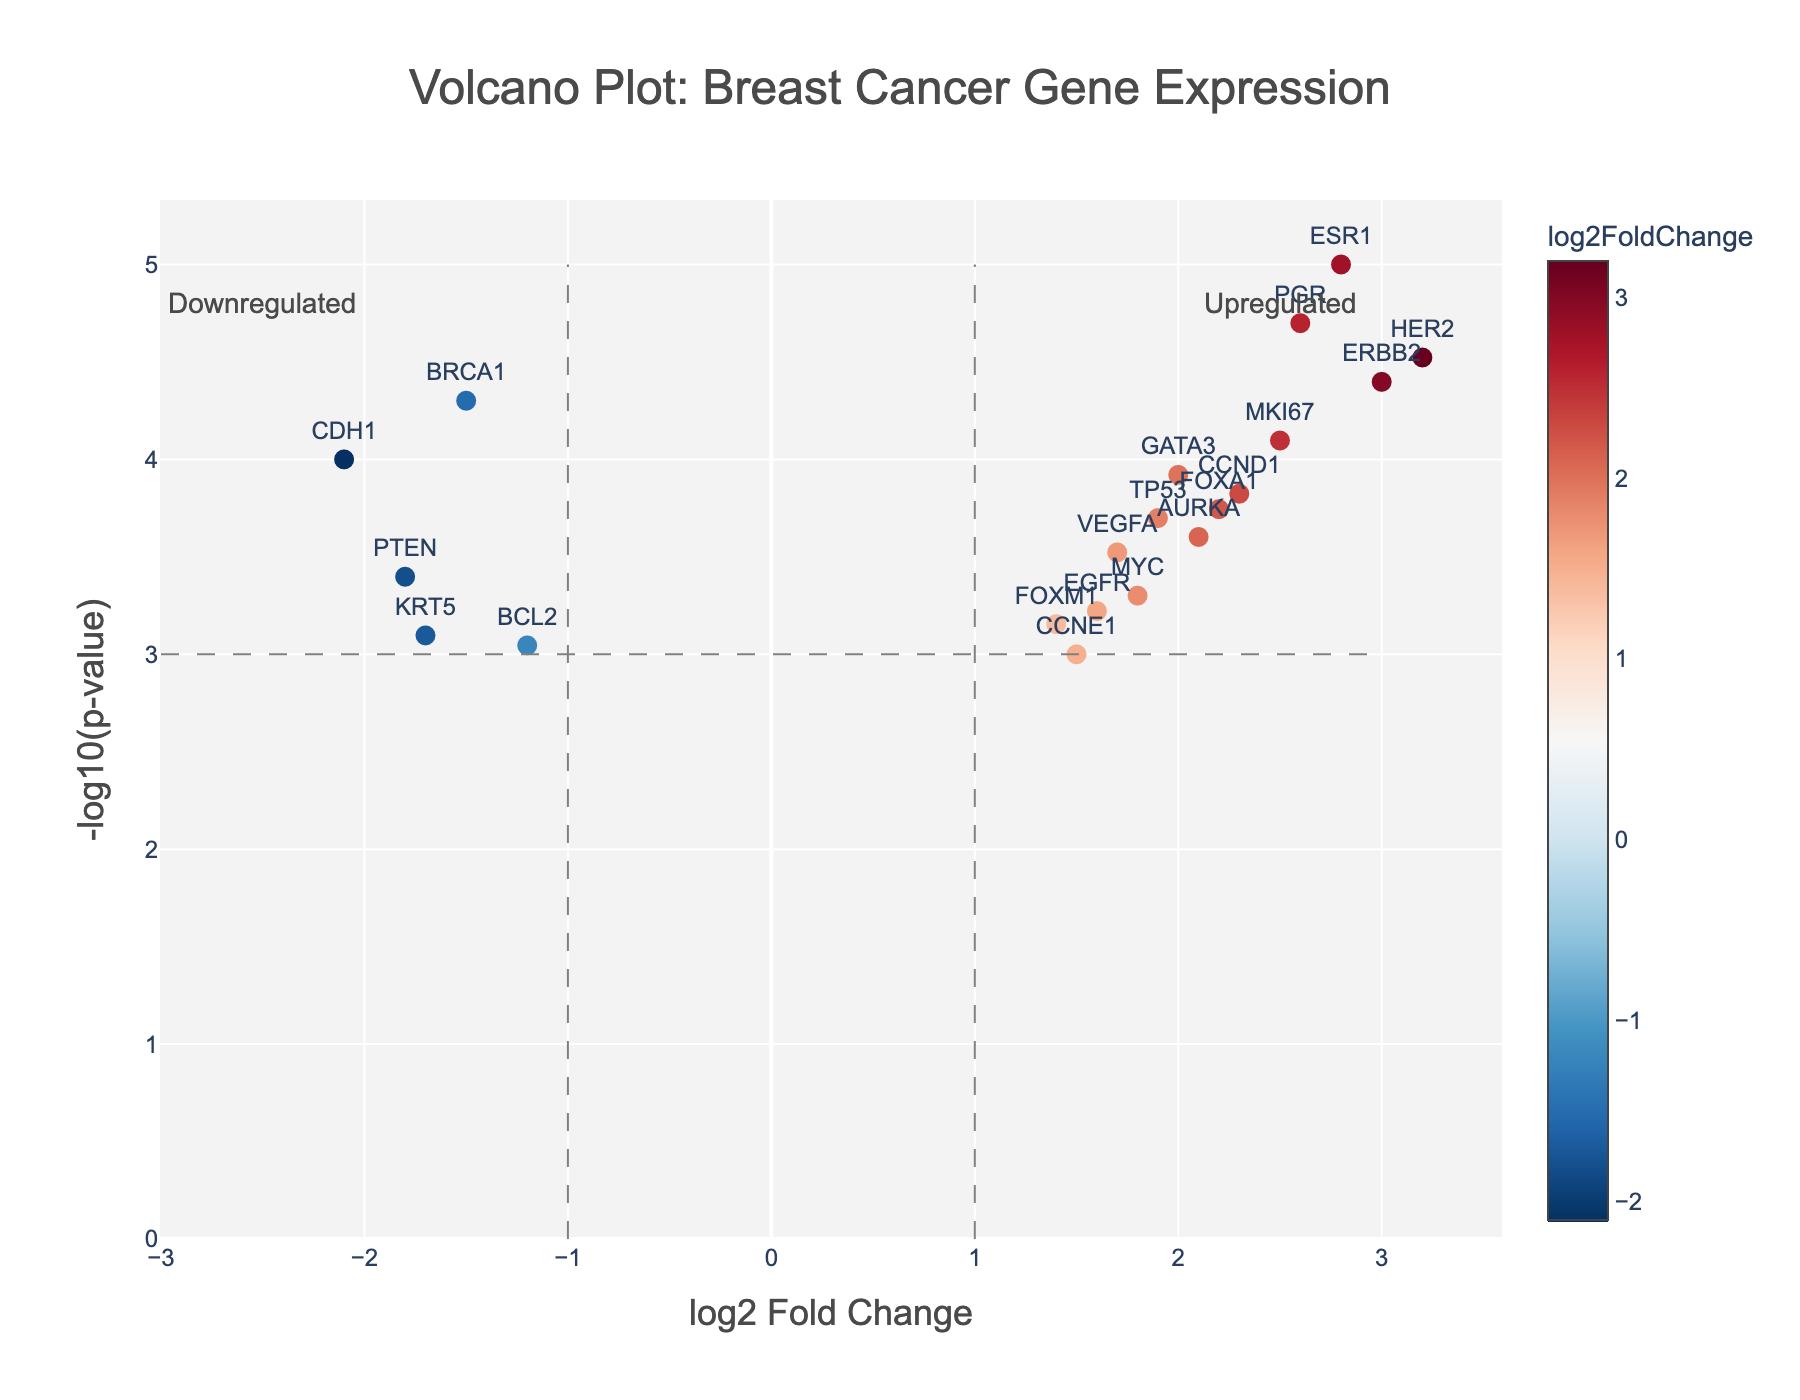What's the title of the plot? The title of the plot is provided at the top in a larger font size. It reads "Volcano Plot: Breast Cancer Gene Expression".
Answer: Volcano Plot: Breast Cancer Gene Expression What do the x-axis and y-axis represent? The x-axis represents the log2 Fold Change, and the y-axis represents the -log10(p-value). This is indicated by the labels along each axis.
Answer: log2 Fold Change for x-axis, -log10(p-value) for y-axis Which gene has the highest log2 Fold Change? To determine this, we look for the data point that is farthest to the right on the x-axis. This point is labeled HER2 and has a log2 Fold Change of 3.2.
Answer: HER2 Which gene is most downregulated? The most downregulated gene will have the lowest log2 Fold Change, appearing farthest to the left on the x-axis. The gene CDH1 has the lowest log2 Fold Change of -2.1.
Answer: CDH1 What is the significance threshold represented by the grey horizontal line? The grey horizontal line across the plot represents a p-value threshold of 0.001, which corresponds to -log10(p-value) = 3. This helps to visually distinguish statistically significant genes.
Answer: -log10(p-value) = 3 How many genes are upregulated with a p-value less than 0.001? Upregulated genes have a positive log2 Fold Change and are above the grey horizontal significance threshold line at -log10(p-value) = 3 (effectively p-value < 0.001). These genes are ESR1, HER2, MKI67, PGR, ERBB2, FOXA1, CCND1, GATA3, AURKA. Counting these, there are nine genes.
Answer: 9 genes Which genes are both significantly upregulated and downregulated? By inspecting the data points above the grey horizontal line at -log10(p-value) = 3 and having either positive or negative log2 Fold changes. Upregulated: ESR1, HER2, MKI67, PGR, ERBB2. Downregulated: BRCA1, CDH1.
Answer: Upregulated: ESR1, HER2, MKI67, PGR, ERBB2; Downregulated: BRCA1, CDH1 What is the log2 Fold Change and p-value for the TP53 gene? The TP53 gene's values can be identified from the hover text or by locating its corresponding data point. TP53 has a log2 Fold Change of 1.9 and a p-value of 0.0002.
Answer: log2 Fold Change: 1.9, p-value: 0.0002 Compare genes ESR1 and BRCA1 in terms of their expression changes and statistical significance. ESR1 is upregulated with a log2 Fold Change of 2.8 and significant at a p-value of 0.00001 (-log10(p-value) = 5). Whereas, BRCA1 is downregulated with a log2 Fold Change of -1.5 and significant at a p-value of 0.00005 (-log10(p-value) = 4.3).
Answer: ESR1: upregulated, more significant; BRCA1: downregulated, less significant 